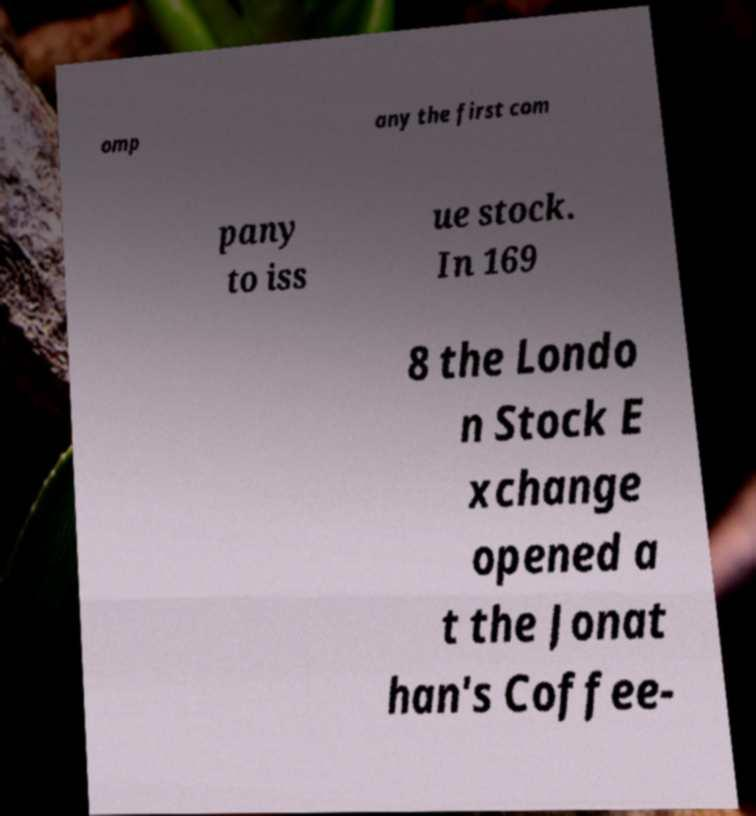Could you extract and type out the text from this image? omp any the first com pany to iss ue stock. In 169 8 the Londo n Stock E xchange opened a t the Jonat han's Coffee- 